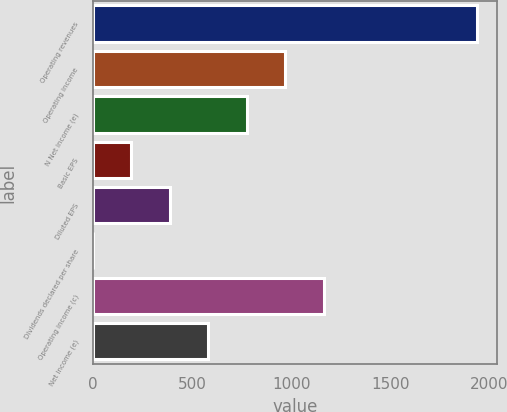Convert chart. <chart><loc_0><loc_0><loc_500><loc_500><bar_chart><fcel>Operating revenues<fcel>Operating income<fcel>N Net income (e)<fcel>Basic EPS<fcel>Diluted EPS<fcel>Dividends declared per share<fcel>Operating income (c)<fcel>Net income (e)<nl><fcel>1939<fcel>969.71<fcel>775.85<fcel>194.27<fcel>388.13<fcel>0.41<fcel>1163.57<fcel>581.99<nl></chart> 